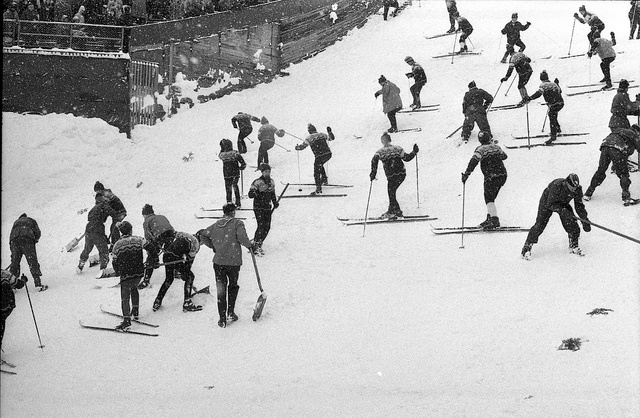Describe the objects in this image and their specific colors. I can see people in black, gray, lightgray, and darkgray tones, people in black, gray, darkgray, and lightgray tones, people in black, gray, lightgray, and darkgray tones, skis in black, white, darkgray, and gray tones, and people in black, gray, darkgray, and lightgray tones in this image. 